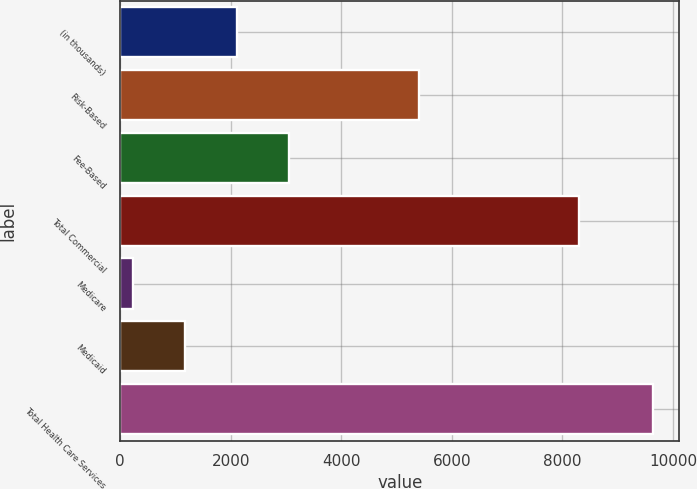<chart> <loc_0><loc_0><loc_500><loc_500><bar_chart><fcel>(in thousands)<fcel>Risk-Based<fcel>Fee-Based<fcel>Total Commercial<fcel>Medicare<fcel>Medicaid<fcel>Total Health Care Services<nl><fcel>2110<fcel>5400<fcel>3050<fcel>8295<fcel>230<fcel>1170<fcel>9630<nl></chart> 